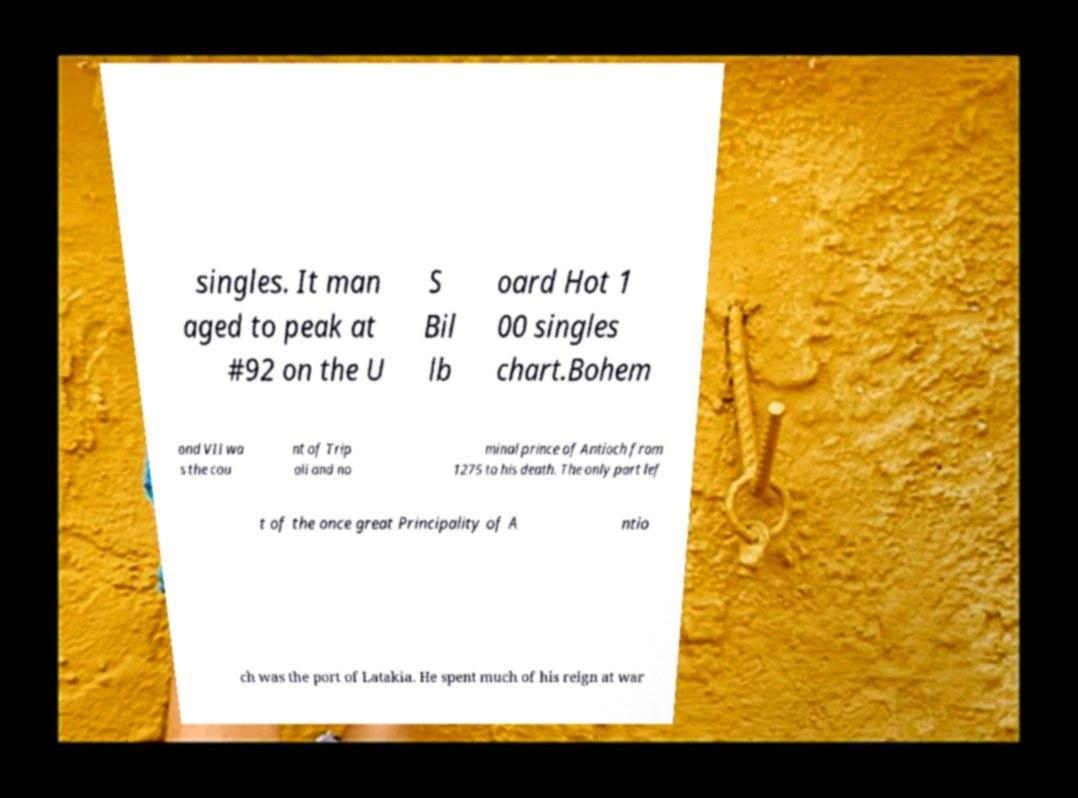Could you extract and type out the text from this image? singles. It man aged to peak at #92 on the U S Bil lb oard Hot 1 00 singles chart.Bohem ond VII wa s the cou nt of Trip oli and no minal prince of Antioch from 1275 to his death. The only part lef t of the once great Principality of A ntio ch was the port of Latakia. He spent much of his reign at war 